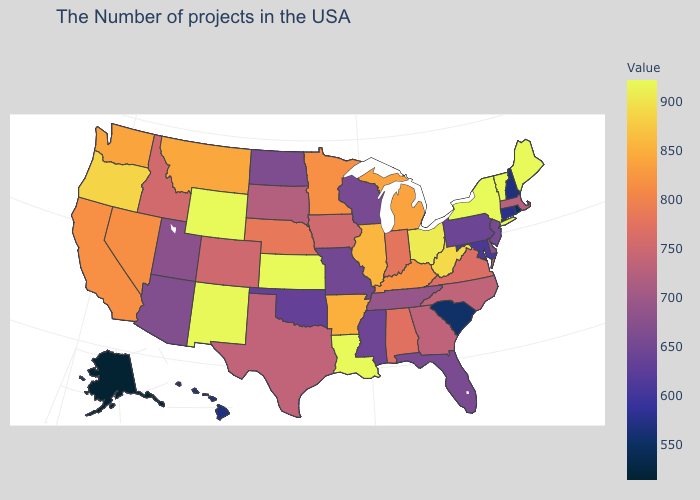Which states have the lowest value in the USA?
Be succinct. Alaska. Among the states that border California , which have the lowest value?
Give a very brief answer. Arizona. Which states have the lowest value in the USA?
Answer briefly. Alaska. 